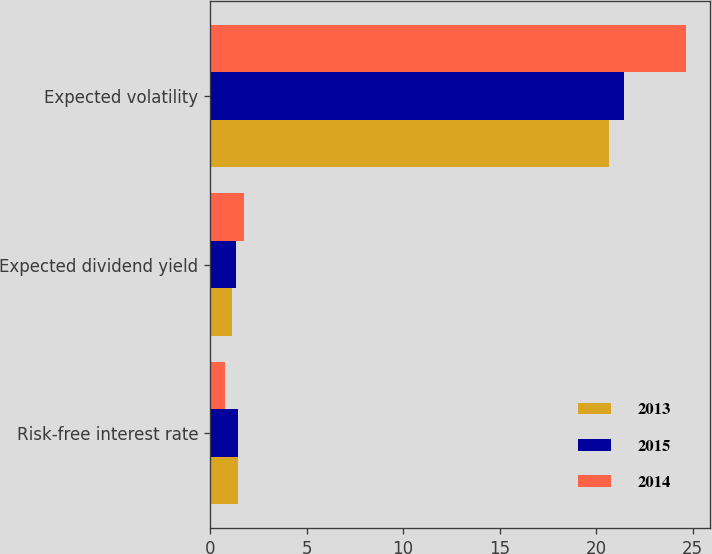<chart> <loc_0><loc_0><loc_500><loc_500><stacked_bar_chart><ecel><fcel>Risk-free interest rate<fcel>Expected dividend yield<fcel>Expected volatility<nl><fcel>2013<fcel>1.44<fcel>1.12<fcel>20.68<nl><fcel>2015<fcel>1.45<fcel>1.34<fcel>21.44<nl><fcel>2014<fcel>0.75<fcel>1.73<fcel>24.65<nl></chart> 